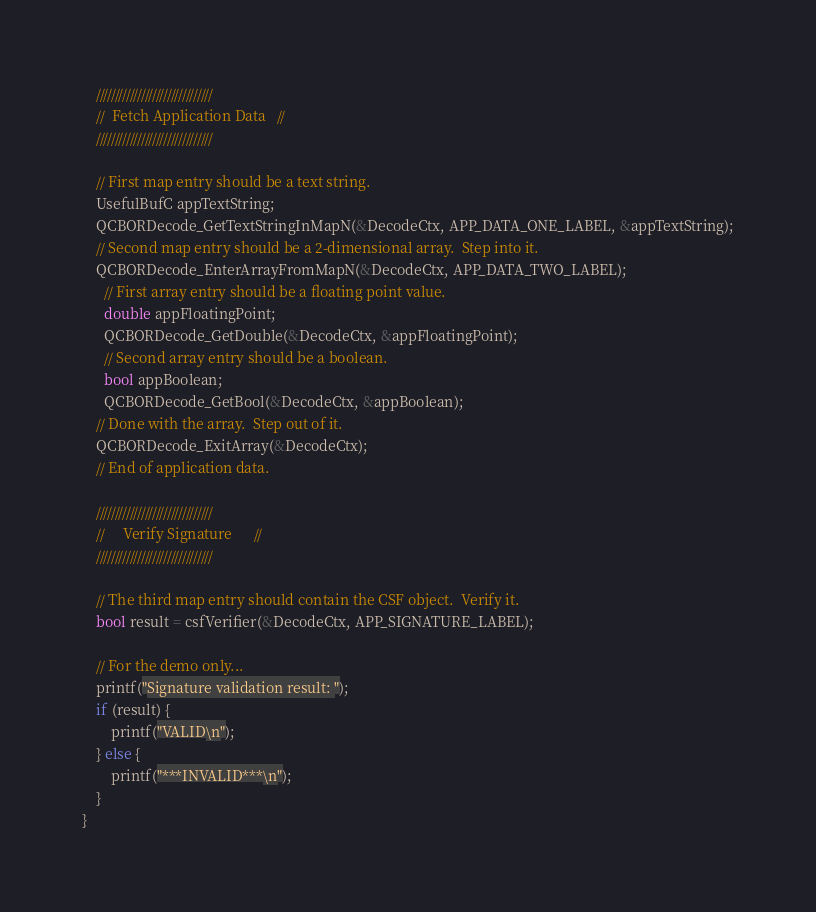Convert code to text. <code><loc_0><loc_0><loc_500><loc_500><_C_>    ///////////////////////////////
    //  Fetch Application Data   //
    ///////////////////////////////
 
    // First map entry should be a text string.
    UsefulBufC appTextString;
    QCBORDecode_GetTextStringInMapN(&DecodeCtx, APP_DATA_ONE_LABEL, &appTextString);
    // Second map entry should be a 2-dimensional array.  Step into it.
    QCBORDecode_EnterArrayFromMapN(&DecodeCtx, APP_DATA_TWO_LABEL);
      // First array entry should be a floating point value.
      double appFloatingPoint;
      QCBORDecode_GetDouble(&DecodeCtx, &appFloatingPoint);
      // Second array entry should be a boolean.
      bool appBoolean;
      QCBORDecode_GetBool(&DecodeCtx, &appBoolean);
    // Done with the array.  Step out of it.
    QCBORDecode_ExitArray(&DecodeCtx);
    // End of application data.

    ///////////////////////////////
    //     Verify Signature      //
    ///////////////////////////////

    // The third map entry should contain the CSF object.  Verify it.
    bool result = csfVerifier(&DecodeCtx, APP_SIGNATURE_LABEL);

    // For the demo only...
    printf("Signature validation result: ");
    if (result) {
        printf("VALID\n");
    } else {
        printf("***INVALID***\n");
    }
}</code> 